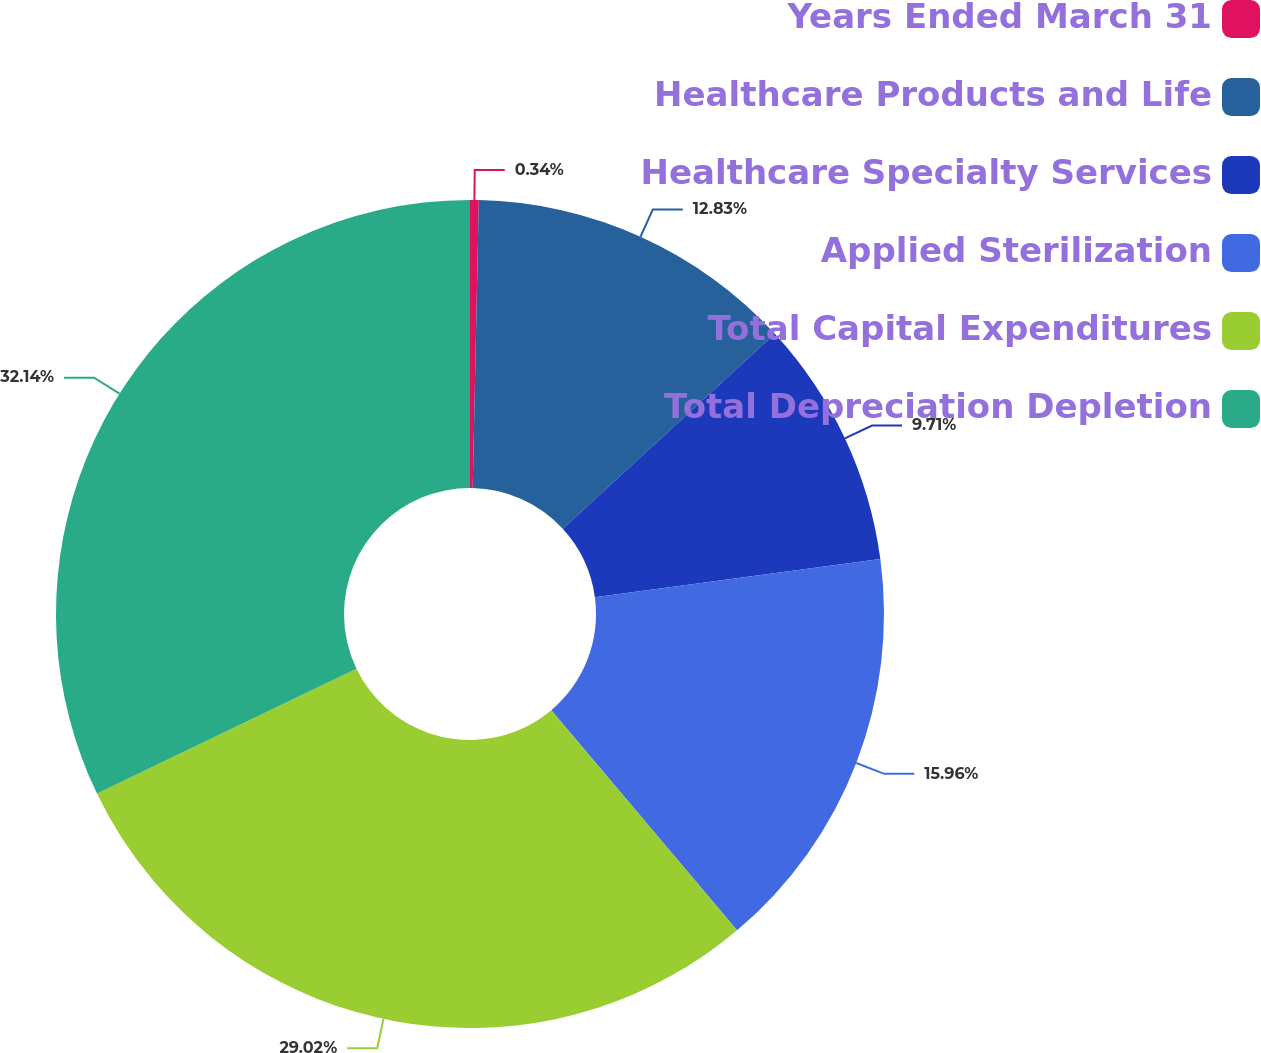Convert chart. <chart><loc_0><loc_0><loc_500><loc_500><pie_chart><fcel>Years Ended March 31<fcel>Healthcare Products and Life<fcel>Healthcare Specialty Services<fcel>Applied Sterilization<fcel>Total Capital Expenditures<fcel>Total Depreciation Depletion<nl><fcel>0.34%<fcel>12.83%<fcel>9.71%<fcel>15.96%<fcel>29.02%<fcel>32.14%<nl></chart> 